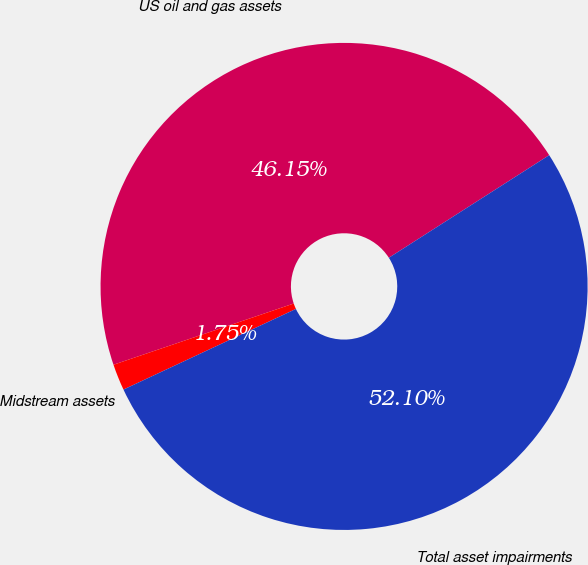<chart> <loc_0><loc_0><loc_500><loc_500><pie_chart><fcel>US oil and gas assets<fcel>Midstream assets<fcel>Total asset impairments<nl><fcel>46.15%<fcel>1.75%<fcel>52.1%<nl></chart> 